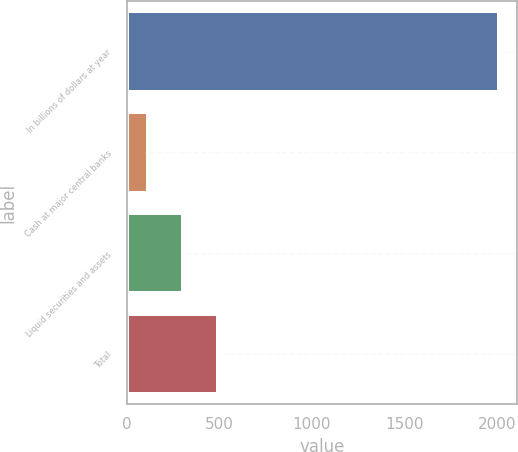<chart> <loc_0><loc_0><loc_500><loc_500><bar_chart><fcel>In billions of dollars at year<fcel>Cash at major central banks<fcel>Liquid securities and assets<fcel>Total<nl><fcel>2009<fcel>115.5<fcel>304.85<fcel>494.2<nl></chart> 